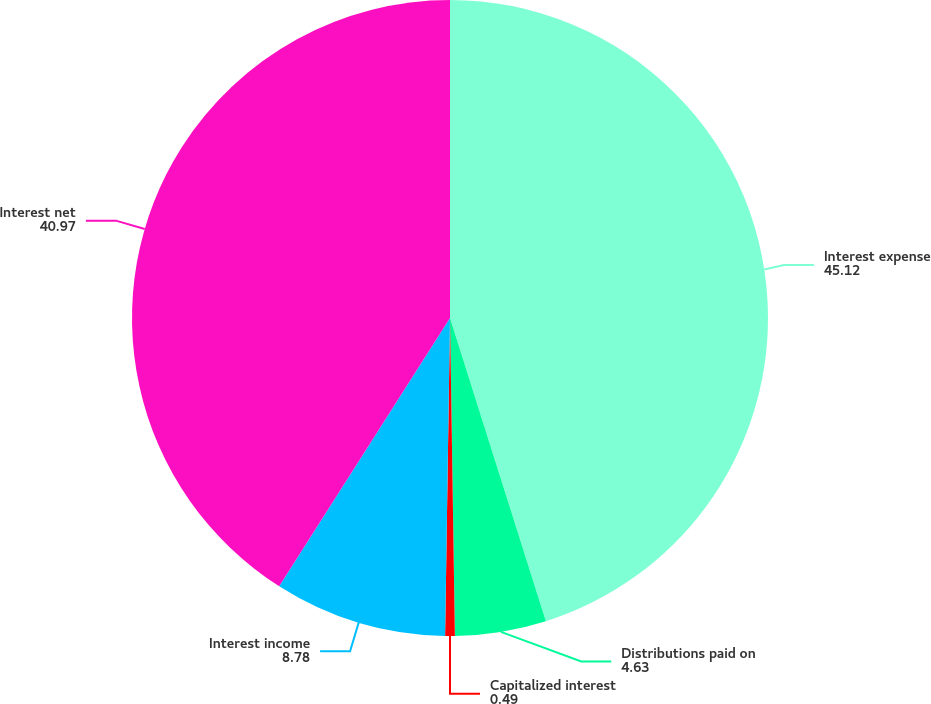<chart> <loc_0><loc_0><loc_500><loc_500><pie_chart><fcel>Interest expense<fcel>Distributions paid on<fcel>Capitalized interest<fcel>Interest income<fcel>Interest net<nl><fcel>45.12%<fcel>4.63%<fcel>0.49%<fcel>8.78%<fcel>40.97%<nl></chart> 